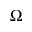<formula> <loc_0><loc_0><loc_500><loc_500>\Omega</formula> 